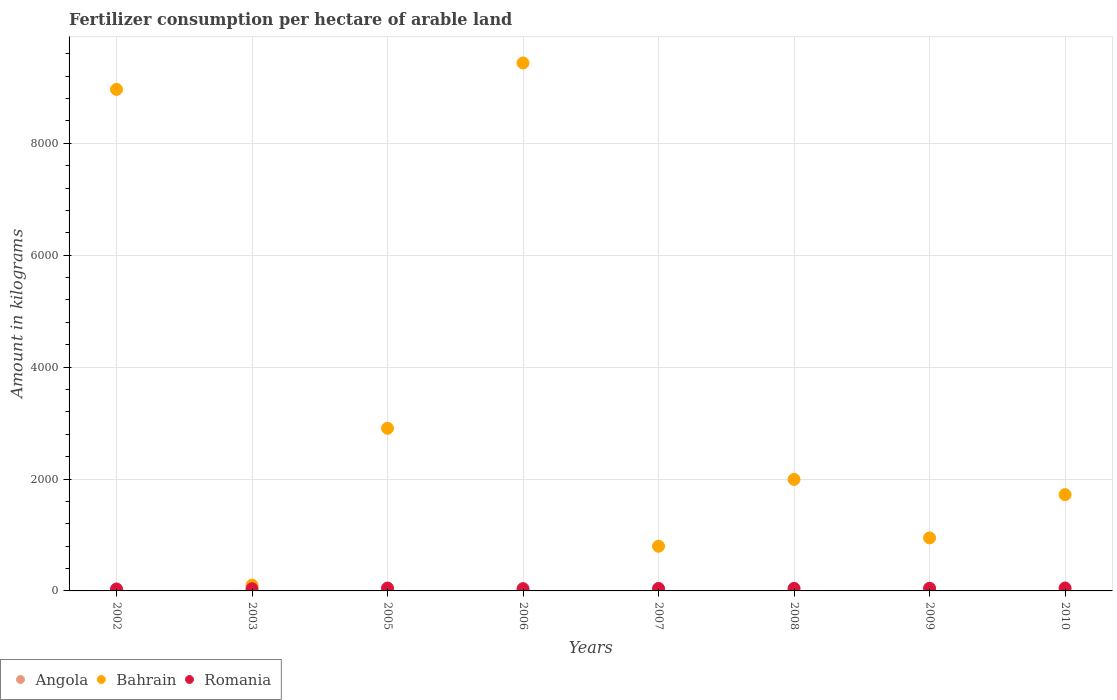What is the amount of fertilizer consumption in Bahrain in 2002?
Ensure brevity in your answer.  8964.5. Across all years, what is the maximum amount of fertilizer consumption in Angola?
Provide a succinct answer. 8.43. Across all years, what is the minimum amount of fertilizer consumption in Angola?
Your response must be concise. 1.66. In which year was the amount of fertilizer consumption in Angola maximum?
Ensure brevity in your answer.  2010. What is the total amount of fertilizer consumption in Romania in the graph?
Your response must be concise. 356.67. What is the difference between the amount of fertilizer consumption in Bahrain in 2009 and that in 2010?
Your answer should be very brief. -773.46. What is the difference between the amount of fertilizer consumption in Angola in 2005 and the amount of fertilizer consumption in Romania in 2007?
Your answer should be compact. -42.38. What is the average amount of fertilizer consumption in Angola per year?
Provide a succinct answer. 4.35. In the year 2007, what is the difference between the amount of fertilizer consumption in Angola and amount of fertilizer consumption in Romania?
Your answer should be very brief. -41.33. What is the ratio of the amount of fertilizer consumption in Romania in 2002 to that in 2009?
Your answer should be compact. 0.72. Is the amount of fertilizer consumption in Bahrain in 2007 less than that in 2008?
Your response must be concise. Yes. Is the difference between the amount of fertilizer consumption in Angola in 2008 and 2009 greater than the difference between the amount of fertilizer consumption in Romania in 2008 and 2009?
Keep it short and to the point. Yes. What is the difference between the highest and the second highest amount of fertilizer consumption in Bahrain?
Your answer should be very brief. 472.05. What is the difference between the highest and the lowest amount of fertilizer consumption in Romania?
Your answer should be compact. 17.76. In how many years, is the amount of fertilizer consumption in Romania greater than the average amount of fertilizer consumption in Romania taken over all years?
Your answer should be compact. 5. Is it the case that in every year, the sum of the amount of fertilizer consumption in Romania and amount of fertilizer consumption in Angola  is greater than the amount of fertilizer consumption in Bahrain?
Your answer should be compact. No. Does the amount of fertilizer consumption in Bahrain monotonically increase over the years?
Offer a terse response. No. Is the amount of fertilizer consumption in Angola strictly greater than the amount of fertilizer consumption in Romania over the years?
Your answer should be very brief. No. How many years are there in the graph?
Your answer should be very brief. 8. What is the difference between two consecutive major ticks on the Y-axis?
Keep it short and to the point. 2000. Does the graph contain any zero values?
Provide a succinct answer. No. Does the graph contain grids?
Offer a terse response. Yes. What is the title of the graph?
Provide a short and direct response. Fertilizer consumption per hectare of arable land. What is the label or title of the X-axis?
Offer a very short reply. Years. What is the label or title of the Y-axis?
Keep it short and to the point. Amount in kilograms. What is the Amount in kilograms in Angola in 2002?
Keep it short and to the point. 1.66. What is the Amount in kilograms of Bahrain in 2002?
Provide a short and direct response. 8964.5. What is the Amount in kilograms of Romania in 2002?
Your response must be concise. 34.78. What is the Amount in kilograms of Angola in 2003?
Ensure brevity in your answer.  1.79. What is the Amount in kilograms in Bahrain in 2003?
Offer a terse response. 103.53. What is the Amount in kilograms in Romania in 2003?
Provide a succinct answer. 38.63. What is the Amount in kilograms of Angola in 2005?
Your response must be concise. 2.26. What is the Amount in kilograms in Bahrain in 2005?
Your answer should be very brief. 2906.67. What is the Amount in kilograms in Romania in 2005?
Your answer should be very brief. 51.35. What is the Amount in kilograms of Angola in 2006?
Make the answer very short. 3.66. What is the Amount in kilograms of Bahrain in 2006?
Your response must be concise. 9436.55. What is the Amount in kilograms in Romania in 2006?
Your answer should be compact. 40.6. What is the Amount in kilograms of Angola in 2007?
Provide a succinct answer. 3.31. What is the Amount in kilograms in Bahrain in 2007?
Offer a terse response. 798.57. What is the Amount in kilograms in Romania in 2007?
Offer a terse response. 44.64. What is the Amount in kilograms in Angola in 2008?
Your response must be concise. 8.26. What is the Amount in kilograms of Bahrain in 2008?
Make the answer very short. 1993.33. What is the Amount in kilograms of Romania in 2008?
Your answer should be compact. 45.64. What is the Amount in kilograms of Angola in 2009?
Your response must be concise. 5.47. What is the Amount in kilograms in Bahrain in 2009?
Ensure brevity in your answer.  947.79. What is the Amount in kilograms in Romania in 2009?
Your answer should be compact. 48.49. What is the Amount in kilograms of Angola in 2010?
Your response must be concise. 8.43. What is the Amount in kilograms of Bahrain in 2010?
Give a very brief answer. 1721.25. What is the Amount in kilograms of Romania in 2010?
Your answer should be very brief. 52.55. Across all years, what is the maximum Amount in kilograms of Angola?
Make the answer very short. 8.43. Across all years, what is the maximum Amount in kilograms in Bahrain?
Your answer should be compact. 9436.55. Across all years, what is the maximum Amount in kilograms in Romania?
Your answer should be very brief. 52.55. Across all years, what is the minimum Amount in kilograms in Angola?
Make the answer very short. 1.66. Across all years, what is the minimum Amount in kilograms in Bahrain?
Your answer should be very brief. 103.53. Across all years, what is the minimum Amount in kilograms of Romania?
Provide a short and direct response. 34.78. What is the total Amount in kilograms in Angola in the graph?
Your answer should be compact. 34.83. What is the total Amount in kilograms of Bahrain in the graph?
Provide a succinct answer. 2.69e+04. What is the total Amount in kilograms of Romania in the graph?
Your answer should be compact. 356.67. What is the difference between the Amount in kilograms in Angola in 2002 and that in 2003?
Your answer should be very brief. -0.13. What is the difference between the Amount in kilograms in Bahrain in 2002 and that in 2003?
Provide a short and direct response. 8860.97. What is the difference between the Amount in kilograms of Romania in 2002 and that in 2003?
Offer a very short reply. -3.85. What is the difference between the Amount in kilograms in Angola in 2002 and that in 2005?
Ensure brevity in your answer.  -0.6. What is the difference between the Amount in kilograms in Bahrain in 2002 and that in 2005?
Your answer should be very brief. 6057.83. What is the difference between the Amount in kilograms in Romania in 2002 and that in 2005?
Provide a short and direct response. -16.57. What is the difference between the Amount in kilograms in Angola in 2002 and that in 2006?
Ensure brevity in your answer.  -2. What is the difference between the Amount in kilograms in Bahrain in 2002 and that in 2006?
Your response must be concise. -472.05. What is the difference between the Amount in kilograms of Romania in 2002 and that in 2006?
Ensure brevity in your answer.  -5.81. What is the difference between the Amount in kilograms of Angola in 2002 and that in 2007?
Give a very brief answer. -1.65. What is the difference between the Amount in kilograms in Bahrain in 2002 and that in 2007?
Your response must be concise. 8165.93. What is the difference between the Amount in kilograms in Romania in 2002 and that in 2007?
Your response must be concise. -9.85. What is the difference between the Amount in kilograms of Angola in 2002 and that in 2008?
Your answer should be compact. -6.6. What is the difference between the Amount in kilograms in Bahrain in 2002 and that in 2008?
Offer a very short reply. 6971.17. What is the difference between the Amount in kilograms of Romania in 2002 and that in 2008?
Your response must be concise. -10.85. What is the difference between the Amount in kilograms of Angola in 2002 and that in 2009?
Your response must be concise. -3.81. What is the difference between the Amount in kilograms in Bahrain in 2002 and that in 2009?
Offer a terse response. 8016.71. What is the difference between the Amount in kilograms of Romania in 2002 and that in 2009?
Keep it short and to the point. -13.71. What is the difference between the Amount in kilograms in Angola in 2002 and that in 2010?
Offer a very short reply. -6.77. What is the difference between the Amount in kilograms in Bahrain in 2002 and that in 2010?
Offer a very short reply. 7243.25. What is the difference between the Amount in kilograms in Romania in 2002 and that in 2010?
Ensure brevity in your answer.  -17.76. What is the difference between the Amount in kilograms of Angola in 2003 and that in 2005?
Offer a very short reply. -0.47. What is the difference between the Amount in kilograms in Bahrain in 2003 and that in 2005?
Keep it short and to the point. -2803.14. What is the difference between the Amount in kilograms in Romania in 2003 and that in 2005?
Your answer should be compact. -12.72. What is the difference between the Amount in kilograms in Angola in 2003 and that in 2006?
Keep it short and to the point. -1.87. What is the difference between the Amount in kilograms in Bahrain in 2003 and that in 2006?
Your answer should be compact. -9333.02. What is the difference between the Amount in kilograms in Romania in 2003 and that in 2006?
Provide a short and direct response. -1.96. What is the difference between the Amount in kilograms of Angola in 2003 and that in 2007?
Your answer should be very brief. -1.52. What is the difference between the Amount in kilograms in Bahrain in 2003 and that in 2007?
Offer a very short reply. -695.04. What is the difference between the Amount in kilograms of Romania in 2003 and that in 2007?
Offer a terse response. -6. What is the difference between the Amount in kilograms of Angola in 2003 and that in 2008?
Offer a very short reply. -6.47. What is the difference between the Amount in kilograms of Bahrain in 2003 and that in 2008?
Keep it short and to the point. -1889.8. What is the difference between the Amount in kilograms of Romania in 2003 and that in 2008?
Offer a very short reply. -7. What is the difference between the Amount in kilograms of Angola in 2003 and that in 2009?
Give a very brief answer. -3.68. What is the difference between the Amount in kilograms of Bahrain in 2003 and that in 2009?
Offer a very short reply. -844.26. What is the difference between the Amount in kilograms in Romania in 2003 and that in 2009?
Provide a short and direct response. -9.86. What is the difference between the Amount in kilograms in Angola in 2003 and that in 2010?
Offer a terse response. -6.64. What is the difference between the Amount in kilograms of Bahrain in 2003 and that in 2010?
Your answer should be compact. -1617.72. What is the difference between the Amount in kilograms of Romania in 2003 and that in 2010?
Provide a succinct answer. -13.91. What is the difference between the Amount in kilograms of Angola in 2005 and that in 2006?
Offer a very short reply. -1.4. What is the difference between the Amount in kilograms in Bahrain in 2005 and that in 2006?
Offer a very short reply. -6529.89. What is the difference between the Amount in kilograms in Romania in 2005 and that in 2006?
Keep it short and to the point. 10.76. What is the difference between the Amount in kilograms in Angola in 2005 and that in 2007?
Make the answer very short. -1.04. What is the difference between the Amount in kilograms of Bahrain in 2005 and that in 2007?
Give a very brief answer. 2108.1. What is the difference between the Amount in kilograms in Romania in 2005 and that in 2007?
Your answer should be compact. 6.72. What is the difference between the Amount in kilograms of Angola in 2005 and that in 2008?
Provide a short and direct response. -6. What is the difference between the Amount in kilograms in Bahrain in 2005 and that in 2008?
Offer a terse response. 913.33. What is the difference between the Amount in kilograms of Romania in 2005 and that in 2008?
Ensure brevity in your answer.  5.72. What is the difference between the Amount in kilograms in Angola in 2005 and that in 2009?
Give a very brief answer. -3.21. What is the difference between the Amount in kilograms in Bahrain in 2005 and that in 2009?
Offer a very short reply. 1958.87. What is the difference between the Amount in kilograms in Romania in 2005 and that in 2009?
Offer a terse response. 2.86. What is the difference between the Amount in kilograms in Angola in 2005 and that in 2010?
Offer a very short reply. -6.17. What is the difference between the Amount in kilograms of Bahrain in 2005 and that in 2010?
Your answer should be compact. 1185.42. What is the difference between the Amount in kilograms of Romania in 2005 and that in 2010?
Your answer should be compact. -1.19. What is the difference between the Amount in kilograms in Angola in 2006 and that in 2007?
Your answer should be very brief. 0.35. What is the difference between the Amount in kilograms of Bahrain in 2006 and that in 2007?
Provide a short and direct response. 8637.98. What is the difference between the Amount in kilograms in Romania in 2006 and that in 2007?
Your response must be concise. -4.04. What is the difference between the Amount in kilograms in Angola in 2006 and that in 2008?
Offer a very short reply. -4.6. What is the difference between the Amount in kilograms in Bahrain in 2006 and that in 2008?
Give a very brief answer. 7443.22. What is the difference between the Amount in kilograms of Romania in 2006 and that in 2008?
Make the answer very short. -5.04. What is the difference between the Amount in kilograms of Angola in 2006 and that in 2009?
Your response must be concise. -1.81. What is the difference between the Amount in kilograms of Bahrain in 2006 and that in 2009?
Make the answer very short. 8488.76. What is the difference between the Amount in kilograms in Romania in 2006 and that in 2009?
Offer a very short reply. -7.9. What is the difference between the Amount in kilograms of Angola in 2006 and that in 2010?
Keep it short and to the point. -4.77. What is the difference between the Amount in kilograms of Bahrain in 2006 and that in 2010?
Offer a terse response. 7715.3. What is the difference between the Amount in kilograms of Romania in 2006 and that in 2010?
Your answer should be very brief. -11.95. What is the difference between the Amount in kilograms in Angola in 2007 and that in 2008?
Make the answer very short. -4.95. What is the difference between the Amount in kilograms of Bahrain in 2007 and that in 2008?
Give a very brief answer. -1194.76. What is the difference between the Amount in kilograms of Romania in 2007 and that in 2008?
Ensure brevity in your answer.  -1. What is the difference between the Amount in kilograms in Angola in 2007 and that in 2009?
Give a very brief answer. -2.17. What is the difference between the Amount in kilograms in Bahrain in 2007 and that in 2009?
Keep it short and to the point. -149.22. What is the difference between the Amount in kilograms in Romania in 2007 and that in 2009?
Offer a very short reply. -3.86. What is the difference between the Amount in kilograms in Angola in 2007 and that in 2010?
Make the answer very short. -5.12. What is the difference between the Amount in kilograms in Bahrain in 2007 and that in 2010?
Provide a succinct answer. -922.68. What is the difference between the Amount in kilograms of Romania in 2007 and that in 2010?
Offer a very short reply. -7.91. What is the difference between the Amount in kilograms of Angola in 2008 and that in 2009?
Provide a short and direct response. 2.79. What is the difference between the Amount in kilograms in Bahrain in 2008 and that in 2009?
Provide a succinct answer. 1045.54. What is the difference between the Amount in kilograms of Romania in 2008 and that in 2009?
Your response must be concise. -2.86. What is the difference between the Amount in kilograms of Angola in 2008 and that in 2010?
Give a very brief answer. -0.17. What is the difference between the Amount in kilograms in Bahrain in 2008 and that in 2010?
Your answer should be very brief. 272.08. What is the difference between the Amount in kilograms in Romania in 2008 and that in 2010?
Your answer should be very brief. -6.91. What is the difference between the Amount in kilograms in Angola in 2009 and that in 2010?
Provide a succinct answer. -2.96. What is the difference between the Amount in kilograms of Bahrain in 2009 and that in 2010?
Your answer should be compact. -773.46. What is the difference between the Amount in kilograms in Romania in 2009 and that in 2010?
Ensure brevity in your answer.  -4.05. What is the difference between the Amount in kilograms of Angola in 2002 and the Amount in kilograms of Bahrain in 2003?
Provide a succinct answer. -101.87. What is the difference between the Amount in kilograms in Angola in 2002 and the Amount in kilograms in Romania in 2003?
Give a very brief answer. -36.97. What is the difference between the Amount in kilograms in Bahrain in 2002 and the Amount in kilograms in Romania in 2003?
Offer a terse response. 8925.87. What is the difference between the Amount in kilograms of Angola in 2002 and the Amount in kilograms of Bahrain in 2005?
Your answer should be very brief. -2905.01. What is the difference between the Amount in kilograms of Angola in 2002 and the Amount in kilograms of Romania in 2005?
Offer a very short reply. -49.69. What is the difference between the Amount in kilograms in Bahrain in 2002 and the Amount in kilograms in Romania in 2005?
Give a very brief answer. 8913.15. What is the difference between the Amount in kilograms in Angola in 2002 and the Amount in kilograms in Bahrain in 2006?
Give a very brief answer. -9434.89. What is the difference between the Amount in kilograms in Angola in 2002 and the Amount in kilograms in Romania in 2006?
Provide a short and direct response. -38.94. What is the difference between the Amount in kilograms of Bahrain in 2002 and the Amount in kilograms of Romania in 2006?
Make the answer very short. 8923.9. What is the difference between the Amount in kilograms in Angola in 2002 and the Amount in kilograms in Bahrain in 2007?
Provide a succinct answer. -796.91. What is the difference between the Amount in kilograms of Angola in 2002 and the Amount in kilograms of Romania in 2007?
Keep it short and to the point. -42.98. What is the difference between the Amount in kilograms in Bahrain in 2002 and the Amount in kilograms in Romania in 2007?
Make the answer very short. 8919.86. What is the difference between the Amount in kilograms in Angola in 2002 and the Amount in kilograms in Bahrain in 2008?
Your answer should be compact. -1991.67. What is the difference between the Amount in kilograms of Angola in 2002 and the Amount in kilograms of Romania in 2008?
Give a very brief answer. -43.98. What is the difference between the Amount in kilograms of Bahrain in 2002 and the Amount in kilograms of Romania in 2008?
Your answer should be very brief. 8918.86. What is the difference between the Amount in kilograms in Angola in 2002 and the Amount in kilograms in Bahrain in 2009?
Offer a terse response. -946.14. What is the difference between the Amount in kilograms in Angola in 2002 and the Amount in kilograms in Romania in 2009?
Ensure brevity in your answer.  -46.83. What is the difference between the Amount in kilograms of Bahrain in 2002 and the Amount in kilograms of Romania in 2009?
Ensure brevity in your answer.  8916.01. What is the difference between the Amount in kilograms of Angola in 2002 and the Amount in kilograms of Bahrain in 2010?
Offer a very short reply. -1719.59. What is the difference between the Amount in kilograms of Angola in 2002 and the Amount in kilograms of Romania in 2010?
Give a very brief answer. -50.89. What is the difference between the Amount in kilograms in Bahrain in 2002 and the Amount in kilograms in Romania in 2010?
Keep it short and to the point. 8911.95. What is the difference between the Amount in kilograms in Angola in 2003 and the Amount in kilograms in Bahrain in 2005?
Keep it short and to the point. -2904.88. What is the difference between the Amount in kilograms of Angola in 2003 and the Amount in kilograms of Romania in 2005?
Your answer should be compact. -49.56. What is the difference between the Amount in kilograms of Bahrain in 2003 and the Amount in kilograms of Romania in 2005?
Provide a short and direct response. 52.18. What is the difference between the Amount in kilograms of Angola in 2003 and the Amount in kilograms of Bahrain in 2006?
Your answer should be compact. -9434.76. What is the difference between the Amount in kilograms of Angola in 2003 and the Amount in kilograms of Romania in 2006?
Offer a terse response. -38.81. What is the difference between the Amount in kilograms of Bahrain in 2003 and the Amount in kilograms of Romania in 2006?
Offer a very short reply. 62.93. What is the difference between the Amount in kilograms of Angola in 2003 and the Amount in kilograms of Bahrain in 2007?
Your answer should be very brief. -796.78. What is the difference between the Amount in kilograms of Angola in 2003 and the Amount in kilograms of Romania in 2007?
Offer a very short reply. -42.85. What is the difference between the Amount in kilograms in Bahrain in 2003 and the Amount in kilograms in Romania in 2007?
Provide a short and direct response. 58.89. What is the difference between the Amount in kilograms of Angola in 2003 and the Amount in kilograms of Bahrain in 2008?
Keep it short and to the point. -1991.54. What is the difference between the Amount in kilograms in Angola in 2003 and the Amount in kilograms in Romania in 2008?
Your response must be concise. -43.85. What is the difference between the Amount in kilograms in Bahrain in 2003 and the Amount in kilograms in Romania in 2008?
Ensure brevity in your answer.  57.89. What is the difference between the Amount in kilograms of Angola in 2003 and the Amount in kilograms of Bahrain in 2009?
Offer a terse response. -946.01. What is the difference between the Amount in kilograms of Angola in 2003 and the Amount in kilograms of Romania in 2009?
Your response must be concise. -46.7. What is the difference between the Amount in kilograms in Bahrain in 2003 and the Amount in kilograms in Romania in 2009?
Offer a very short reply. 55.04. What is the difference between the Amount in kilograms of Angola in 2003 and the Amount in kilograms of Bahrain in 2010?
Give a very brief answer. -1719.46. What is the difference between the Amount in kilograms in Angola in 2003 and the Amount in kilograms in Romania in 2010?
Make the answer very short. -50.76. What is the difference between the Amount in kilograms of Bahrain in 2003 and the Amount in kilograms of Romania in 2010?
Offer a terse response. 50.98. What is the difference between the Amount in kilograms in Angola in 2005 and the Amount in kilograms in Bahrain in 2006?
Provide a succinct answer. -9434.29. What is the difference between the Amount in kilograms in Angola in 2005 and the Amount in kilograms in Romania in 2006?
Keep it short and to the point. -38.34. What is the difference between the Amount in kilograms of Bahrain in 2005 and the Amount in kilograms of Romania in 2006?
Ensure brevity in your answer.  2866.07. What is the difference between the Amount in kilograms of Angola in 2005 and the Amount in kilograms of Bahrain in 2007?
Your response must be concise. -796.31. What is the difference between the Amount in kilograms in Angola in 2005 and the Amount in kilograms in Romania in 2007?
Provide a short and direct response. -42.38. What is the difference between the Amount in kilograms in Bahrain in 2005 and the Amount in kilograms in Romania in 2007?
Your response must be concise. 2862.03. What is the difference between the Amount in kilograms in Angola in 2005 and the Amount in kilograms in Bahrain in 2008?
Provide a succinct answer. -1991.07. What is the difference between the Amount in kilograms of Angola in 2005 and the Amount in kilograms of Romania in 2008?
Your answer should be very brief. -43.37. What is the difference between the Amount in kilograms in Bahrain in 2005 and the Amount in kilograms in Romania in 2008?
Give a very brief answer. 2861.03. What is the difference between the Amount in kilograms of Angola in 2005 and the Amount in kilograms of Bahrain in 2009?
Give a very brief answer. -945.53. What is the difference between the Amount in kilograms in Angola in 2005 and the Amount in kilograms in Romania in 2009?
Your response must be concise. -46.23. What is the difference between the Amount in kilograms in Bahrain in 2005 and the Amount in kilograms in Romania in 2009?
Make the answer very short. 2858.17. What is the difference between the Amount in kilograms in Angola in 2005 and the Amount in kilograms in Bahrain in 2010?
Ensure brevity in your answer.  -1718.99. What is the difference between the Amount in kilograms of Angola in 2005 and the Amount in kilograms of Romania in 2010?
Your answer should be compact. -50.29. What is the difference between the Amount in kilograms in Bahrain in 2005 and the Amount in kilograms in Romania in 2010?
Keep it short and to the point. 2854.12. What is the difference between the Amount in kilograms of Angola in 2006 and the Amount in kilograms of Bahrain in 2007?
Give a very brief answer. -794.91. What is the difference between the Amount in kilograms in Angola in 2006 and the Amount in kilograms in Romania in 2007?
Provide a short and direct response. -40.98. What is the difference between the Amount in kilograms in Bahrain in 2006 and the Amount in kilograms in Romania in 2007?
Ensure brevity in your answer.  9391.92. What is the difference between the Amount in kilograms in Angola in 2006 and the Amount in kilograms in Bahrain in 2008?
Ensure brevity in your answer.  -1989.67. What is the difference between the Amount in kilograms of Angola in 2006 and the Amount in kilograms of Romania in 2008?
Your answer should be very brief. -41.98. What is the difference between the Amount in kilograms of Bahrain in 2006 and the Amount in kilograms of Romania in 2008?
Provide a succinct answer. 9390.92. What is the difference between the Amount in kilograms of Angola in 2006 and the Amount in kilograms of Bahrain in 2009?
Your answer should be compact. -944.13. What is the difference between the Amount in kilograms in Angola in 2006 and the Amount in kilograms in Romania in 2009?
Your answer should be very brief. -44.83. What is the difference between the Amount in kilograms in Bahrain in 2006 and the Amount in kilograms in Romania in 2009?
Ensure brevity in your answer.  9388.06. What is the difference between the Amount in kilograms in Angola in 2006 and the Amount in kilograms in Bahrain in 2010?
Ensure brevity in your answer.  -1717.59. What is the difference between the Amount in kilograms of Angola in 2006 and the Amount in kilograms of Romania in 2010?
Your response must be concise. -48.89. What is the difference between the Amount in kilograms of Bahrain in 2006 and the Amount in kilograms of Romania in 2010?
Offer a terse response. 9384.01. What is the difference between the Amount in kilograms of Angola in 2007 and the Amount in kilograms of Bahrain in 2008?
Provide a short and direct response. -1990.03. What is the difference between the Amount in kilograms of Angola in 2007 and the Amount in kilograms of Romania in 2008?
Your answer should be compact. -42.33. What is the difference between the Amount in kilograms in Bahrain in 2007 and the Amount in kilograms in Romania in 2008?
Provide a succinct answer. 752.94. What is the difference between the Amount in kilograms of Angola in 2007 and the Amount in kilograms of Bahrain in 2009?
Ensure brevity in your answer.  -944.49. What is the difference between the Amount in kilograms of Angola in 2007 and the Amount in kilograms of Romania in 2009?
Your response must be concise. -45.19. What is the difference between the Amount in kilograms in Bahrain in 2007 and the Amount in kilograms in Romania in 2009?
Your response must be concise. 750.08. What is the difference between the Amount in kilograms of Angola in 2007 and the Amount in kilograms of Bahrain in 2010?
Your response must be concise. -1717.94. What is the difference between the Amount in kilograms of Angola in 2007 and the Amount in kilograms of Romania in 2010?
Offer a very short reply. -49.24. What is the difference between the Amount in kilograms of Bahrain in 2007 and the Amount in kilograms of Romania in 2010?
Offer a terse response. 746.03. What is the difference between the Amount in kilograms of Angola in 2008 and the Amount in kilograms of Bahrain in 2009?
Ensure brevity in your answer.  -939.54. What is the difference between the Amount in kilograms of Angola in 2008 and the Amount in kilograms of Romania in 2009?
Provide a succinct answer. -40.23. What is the difference between the Amount in kilograms of Bahrain in 2008 and the Amount in kilograms of Romania in 2009?
Make the answer very short. 1944.84. What is the difference between the Amount in kilograms in Angola in 2008 and the Amount in kilograms in Bahrain in 2010?
Make the answer very short. -1712.99. What is the difference between the Amount in kilograms in Angola in 2008 and the Amount in kilograms in Romania in 2010?
Give a very brief answer. -44.29. What is the difference between the Amount in kilograms in Bahrain in 2008 and the Amount in kilograms in Romania in 2010?
Make the answer very short. 1940.79. What is the difference between the Amount in kilograms of Angola in 2009 and the Amount in kilograms of Bahrain in 2010?
Your answer should be very brief. -1715.78. What is the difference between the Amount in kilograms in Angola in 2009 and the Amount in kilograms in Romania in 2010?
Give a very brief answer. -47.07. What is the difference between the Amount in kilograms in Bahrain in 2009 and the Amount in kilograms in Romania in 2010?
Provide a short and direct response. 895.25. What is the average Amount in kilograms in Angola per year?
Make the answer very short. 4.35. What is the average Amount in kilograms of Bahrain per year?
Offer a very short reply. 3359.02. What is the average Amount in kilograms in Romania per year?
Give a very brief answer. 44.58. In the year 2002, what is the difference between the Amount in kilograms of Angola and Amount in kilograms of Bahrain?
Your answer should be compact. -8962.84. In the year 2002, what is the difference between the Amount in kilograms of Angola and Amount in kilograms of Romania?
Keep it short and to the point. -33.12. In the year 2002, what is the difference between the Amount in kilograms in Bahrain and Amount in kilograms in Romania?
Ensure brevity in your answer.  8929.72. In the year 2003, what is the difference between the Amount in kilograms in Angola and Amount in kilograms in Bahrain?
Your answer should be very brief. -101.74. In the year 2003, what is the difference between the Amount in kilograms in Angola and Amount in kilograms in Romania?
Your answer should be very brief. -36.84. In the year 2003, what is the difference between the Amount in kilograms in Bahrain and Amount in kilograms in Romania?
Offer a very short reply. 64.9. In the year 2005, what is the difference between the Amount in kilograms in Angola and Amount in kilograms in Bahrain?
Make the answer very short. -2904.41. In the year 2005, what is the difference between the Amount in kilograms in Angola and Amount in kilograms in Romania?
Your response must be concise. -49.09. In the year 2005, what is the difference between the Amount in kilograms of Bahrain and Amount in kilograms of Romania?
Make the answer very short. 2855.32. In the year 2006, what is the difference between the Amount in kilograms in Angola and Amount in kilograms in Bahrain?
Provide a short and direct response. -9432.89. In the year 2006, what is the difference between the Amount in kilograms in Angola and Amount in kilograms in Romania?
Ensure brevity in your answer.  -36.94. In the year 2006, what is the difference between the Amount in kilograms in Bahrain and Amount in kilograms in Romania?
Provide a succinct answer. 9395.96. In the year 2007, what is the difference between the Amount in kilograms in Angola and Amount in kilograms in Bahrain?
Your answer should be compact. -795.27. In the year 2007, what is the difference between the Amount in kilograms of Angola and Amount in kilograms of Romania?
Your response must be concise. -41.33. In the year 2007, what is the difference between the Amount in kilograms in Bahrain and Amount in kilograms in Romania?
Provide a short and direct response. 753.94. In the year 2008, what is the difference between the Amount in kilograms of Angola and Amount in kilograms of Bahrain?
Provide a short and direct response. -1985.07. In the year 2008, what is the difference between the Amount in kilograms of Angola and Amount in kilograms of Romania?
Make the answer very short. -37.38. In the year 2008, what is the difference between the Amount in kilograms of Bahrain and Amount in kilograms of Romania?
Your response must be concise. 1947.7. In the year 2009, what is the difference between the Amount in kilograms in Angola and Amount in kilograms in Bahrain?
Provide a succinct answer. -942.32. In the year 2009, what is the difference between the Amount in kilograms in Angola and Amount in kilograms in Romania?
Offer a very short reply. -43.02. In the year 2009, what is the difference between the Amount in kilograms in Bahrain and Amount in kilograms in Romania?
Your answer should be compact. 899.3. In the year 2010, what is the difference between the Amount in kilograms of Angola and Amount in kilograms of Bahrain?
Your answer should be compact. -1712.82. In the year 2010, what is the difference between the Amount in kilograms of Angola and Amount in kilograms of Romania?
Keep it short and to the point. -44.12. In the year 2010, what is the difference between the Amount in kilograms of Bahrain and Amount in kilograms of Romania?
Provide a short and direct response. 1668.7. What is the ratio of the Amount in kilograms in Angola in 2002 to that in 2003?
Your answer should be very brief. 0.93. What is the ratio of the Amount in kilograms in Bahrain in 2002 to that in 2003?
Make the answer very short. 86.59. What is the ratio of the Amount in kilograms of Romania in 2002 to that in 2003?
Provide a short and direct response. 0.9. What is the ratio of the Amount in kilograms of Angola in 2002 to that in 2005?
Offer a terse response. 0.73. What is the ratio of the Amount in kilograms of Bahrain in 2002 to that in 2005?
Keep it short and to the point. 3.08. What is the ratio of the Amount in kilograms in Romania in 2002 to that in 2005?
Keep it short and to the point. 0.68. What is the ratio of the Amount in kilograms in Angola in 2002 to that in 2006?
Offer a terse response. 0.45. What is the ratio of the Amount in kilograms in Bahrain in 2002 to that in 2006?
Your response must be concise. 0.95. What is the ratio of the Amount in kilograms in Romania in 2002 to that in 2006?
Make the answer very short. 0.86. What is the ratio of the Amount in kilograms in Angola in 2002 to that in 2007?
Offer a terse response. 0.5. What is the ratio of the Amount in kilograms in Bahrain in 2002 to that in 2007?
Offer a very short reply. 11.23. What is the ratio of the Amount in kilograms of Romania in 2002 to that in 2007?
Provide a short and direct response. 0.78. What is the ratio of the Amount in kilograms of Angola in 2002 to that in 2008?
Your answer should be very brief. 0.2. What is the ratio of the Amount in kilograms of Bahrain in 2002 to that in 2008?
Provide a short and direct response. 4.5. What is the ratio of the Amount in kilograms in Romania in 2002 to that in 2008?
Provide a short and direct response. 0.76. What is the ratio of the Amount in kilograms in Angola in 2002 to that in 2009?
Provide a succinct answer. 0.3. What is the ratio of the Amount in kilograms of Bahrain in 2002 to that in 2009?
Offer a very short reply. 9.46. What is the ratio of the Amount in kilograms in Romania in 2002 to that in 2009?
Give a very brief answer. 0.72. What is the ratio of the Amount in kilograms of Angola in 2002 to that in 2010?
Ensure brevity in your answer.  0.2. What is the ratio of the Amount in kilograms in Bahrain in 2002 to that in 2010?
Your answer should be compact. 5.21. What is the ratio of the Amount in kilograms of Romania in 2002 to that in 2010?
Make the answer very short. 0.66. What is the ratio of the Amount in kilograms in Angola in 2003 to that in 2005?
Your answer should be very brief. 0.79. What is the ratio of the Amount in kilograms in Bahrain in 2003 to that in 2005?
Provide a succinct answer. 0.04. What is the ratio of the Amount in kilograms of Romania in 2003 to that in 2005?
Make the answer very short. 0.75. What is the ratio of the Amount in kilograms of Angola in 2003 to that in 2006?
Ensure brevity in your answer.  0.49. What is the ratio of the Amount in kilograms of Bahrain in 2003 to that in 2006?
Ensure brevity in your answer.  0.01. What is the ratio of the Amount in kilograms in Romania in 2003 to that in 2006?
Ensure brevity in your answer.  0.95. What is the ratio of the Amount in kilograms in Angola in 2003 to that in 2007?
Keep it short and to the point. 0.54. What is the ratio of the Amount in kilograms of Bahrain in 2003 to that in 2007?
Provide a short and direct response. 0.13. What is the ratio of the Amount in kilograms in Romania in 2003 to that in 2007?
Keep it short and to the point. 0.87. What is the ratio of the Amount in kilograms in Angola in 2003 to that in 2008?
Provide a succinct answer. 0.22. What is the ratio of the Amount in kilograms in Bahrain in 2003 to that in 2008?
Your answer should be very brief. 0.05. What is the ratio of the Amount in kilograms in Romania in 2003 to that in 2008?
Keep it short and to the point. 0.85. What is the ratio of the Amount in kilograms in Angola in 2003 to that in 2009?
Ensure brevity in your answer.  0.33. What is the ratio of the Amount in kilograms of Bahrain in 2003 to that in 2009?
Offer a very short reply. 0.11. What is the ratio of the Amount in kilograms of Romania in 2003 to that in 2009?
Keep it short and to the point. 0.8. What is the ratio of the Amount in kilograms in Angola in 2003 to that in 2010?
Ensure brevity in your answer.  0.21. What is the ratio of the Amount in kilograms of Bahrain in 2003 to that in 2010?
Offer a terse response. 0.06. What is the ratio of the Amount in kilograms of Romania in 2003 to that in 2010?
Make the answer very short. 0.74. What is the ratio of the Amount in kilograms in Angola in 2005 to that in 2006?
Your answer should be very brief. 0.62. What is the ratio of the Amount in kilograms of Bahrain in 2005 to that in 2006?
Your answer should be compact. 0.31. What is the ratio of the Amount in kilograms in Romania in 2005 to that in 2006?
Make the answer very short. 1.26. What is the ratio of the Amount in kilograms in Angola in 2005 to that in 2007?
Provide a short and direct response. 0.68. What is the ratio of the Amount in kilograms of Bahrain in 2005 to that in 2007?
Provide a succinct answer. 3.64. What is the ratio of the Amount in kilograms in Romania in 2005 to that in 2007?
Make the answer very short. 1.15. What is the ratio of the Amount in kilograms of Angola in 2005 to that in 2008?
Give a very brief answer. 0.27. What is the ratio of the Amount in kilograms of Bahrain in 2005 to that in 2008?
Keep it short and to the point. 1.46. What is the ratio of the Amount in kilograms in Romania in 2005 to that in 2008?
Your response must be concise. 1.13. What is the ratio of the Amount in kilograms of Angola in 2005 to that in 2009?
Offer a very short reply. 0.41. What is the ratio of the Amount in kilograms in Bahrain in 2005 to that in 2009?
Offer a very short reply. 3.07. What is the ratio of the Amount in kilograms in Romania in 2005 to that in 2009?
Provide a short and direct response. 1.06. What is the ratio of the Amount in kilograms of Angola in 2005 to that in 2010?
Your answer should be compact. 0.27. What is the ratio of the Amount in kilograms of Bahrain in 2005 to that in 2010?
Keep it short and to the point. 1.69. What is the ratio of the Amount in kilograms in Romania in 2005 to that in 2010?
Make the answer very short. 0.98. What is the ratio of the Amount in kilograms of Angola in 2006 to that in 2007?
Give a very brief answer. 1.11. What is the ratio of the Amount in kilograms in Bahrain in 2006 to that in 2007?
Your answer should be compact. 11.82. What is the ratio of the Amount in kilograms in Romania in 2006 to that in 2007?
Offer a terse response. 0.91. What is the ratio of the Amount in kilograms of Angola in 2006 to that in 2008?
Your response must be concise. 0.44. What is the ratio of the Amount in kilograms in Bahrain in 2006 to that in 2008?
Keep it short and to the point. 4.73. What is the ratio of the Amount in kilograms of Romania in 2006 to that in 2008?
Provide a succinct answer. 0.89. What is the ratio of the Amount in kilograms in Angola in 2006 to that in 2009?
Offer a very short reply. 0.67. What is the ratio of the Amount in kilograms of Bahrain in 2006 to that in 2009?
Your answer should be very brief. 9.96. What is the ratio of the Amount in kilograms in Romania in 2006 to that in 2009?
Offer a very short reply. 0.84. What is the ratio of the Amount in kilograms in Angola in 2006 to that in 2010?
Offer a very short reply. 0.43. What is the ratio of the Amount in kilograms of Bahrain in 2006 to that in 2010?
Make the answer very short. 5.48. What is the ratio of the Amount in kilograms in Romania in 2006 to that in 2010?
Keep it short and to the point. 0.77. What is the ratio of the Amount in kilograms in Angola in 2007 to that in 2008?
Offer a very short reply. 0.4. What is the ratio of the Amount in kilograms in Bahrain in 2007 to that in 2008?
Offer a terse response. 0.4. What is the ratio of the Amount in kilograms in Romania in 2007 to that in 2008?
Make the answer very short. 0.98. What is the ratio of the Amount in kilograms in Angola in 2007 to that in 2009?
Make the answer very short. 0.6. What is the ratio of the Amount in kilograms of Bahrain in 2007 to that in 2009?
Your answer should be very brief. 0.84. What is the ratio of the Amount in kilograms of Romania in 2007 to that in 2009?
Give a very brief answer. 0.92. What is the ratio of the Amount in kilograms in Angola in 2007 to that in 2010?
Ensure brevity in your answer.  0.39. What is the ratio of the Amount in kilograms of Bahrain in 2007 to that in 2010?
Ensure brevity in your answer.  0.46. What is the ratio of the Amount in kilograms in Romania in 2007 to that in 2010?
Your response must be concise. 0.85. What is the ratio of the Amount in kilograms of Angola in 2008 to that in 2009?
Your answer should be very brief. 1.51. What is the ratio of the Amount in kilograms of Bahrain in 2008 to that in 2009?
Make the answer very short. 2.1. What is the ratio of the Amount in kilograms in Romania in 2008 to that in 2009?
Offer a very short reply. 0.94. What is the ratio of the Amount in kilograms in Angola in 2008 to that in 2010?
Offer a very short reply. 0.98. What is the ratio of the Amount in kilograms of Bahrain in 2008 to that in 2010?
Make the answer very short. 1.16. What is the ratio of the Amount in kilograms of Romania in 2008 to that in 2010?
Your answer should be compact. 0.87. What is the ratio of the Amount in kilograms of Angola in 2009 to that in 2010?
Offer a terse response. 0.65. What is the ratio of the Amount in kilograms in Bahrain in 2009 to that in 2010?
Keep it short and to the point. 0.55. What is the ratio of the Amount in kilograms in Romania in 2009 to that in 2010?
Offer a very short reply. 0.92. What is the difference between the highest and the second highest Amount in kilograms in Angola?
Your answer should be compact. 0.17. What is the difference between the highest and the second highest Amount in kilograms of Bahrain?
Ensure brevity in your answer.  472.05. What is the difference between the highest and the second highest Amount in kilograms of Romania?
Give a very brief answer. 1.19. What is the difference between the highest and the lowest Amount in kilograms of Angola?
Keep it short and to the point. 6.77. What is the difference between the highest and the lowest Amount in kilograms of Bahrain?
Provide a succinct answer. 9333.02. What is the difference between the highest and the lowest Amount in kilograms of Romania?
Provide a short and direct response. 17.76. 